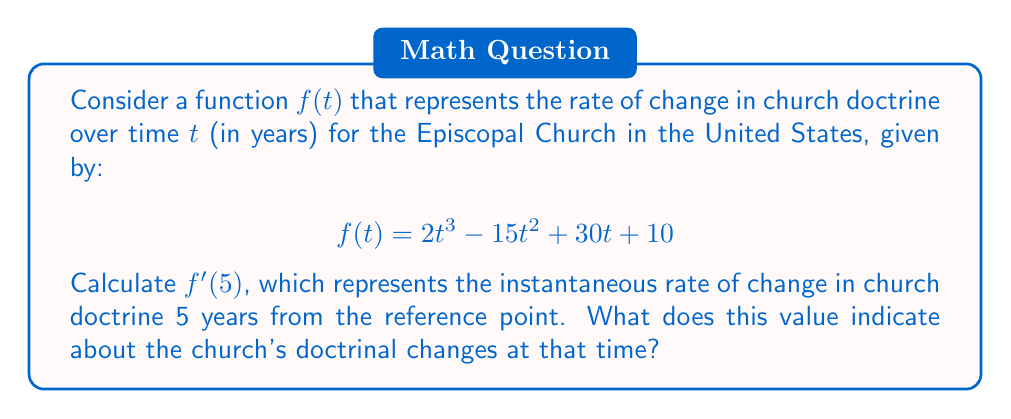Solve this math problem. To solve this problem, we need to follow these steps:

1) First, we need to find the derivative of the function $f(t)$. Let's call this derivative $f'(t)$.

   $$f(t) = 2t^3 - 15t^2 + 30t + 10$$

   Using the power rule and the constant rule of differentiation:
   
   $$f'(t) = 6t^2 - 30t + 30$$

2) Now that we have $f'(t)$, we need to evaluate it at $t=5$:

   $$f'(5) = 6(5)^2 - 30(5) + 30$$

3) Let's calculate this step by step:
   
   $$f'(5) = 6(25) - 150 + 30$$
   $$f'(5) = 150 - 150 + 30$$
   $$f'(5) = 30$$

4) Interpretation: The value of $f'(5) = 30$ represents the instantaneous rate of change in church doctrine 5 years from the reference point. Since this value is positive, it indicates that at this point in time, the church's doctrine was changing at a rate of 30 units per year in a direction that might be considered "progressive" or "liberal" by some members.
Answer: $f'(5) = 30$, indicating that 5 years from the reference point, the church's doctrine was changing at a rate of 30 units per year in a direction that some members might consider progressive or liberal. 